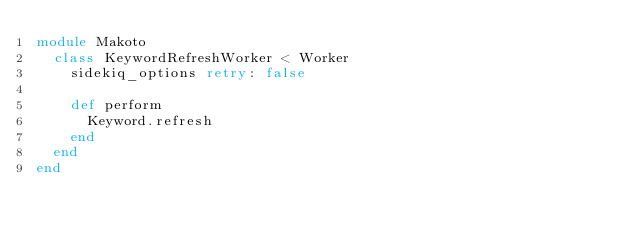<code> <loc_0><loc_0><loc_500><loc_500><_Ruby_>module Makoto
  class KeywordRefreshWorker < Worker
    sidekiq_options retry: false

    def perform
      Keyword.refresh
    end
  end
end
</code> 